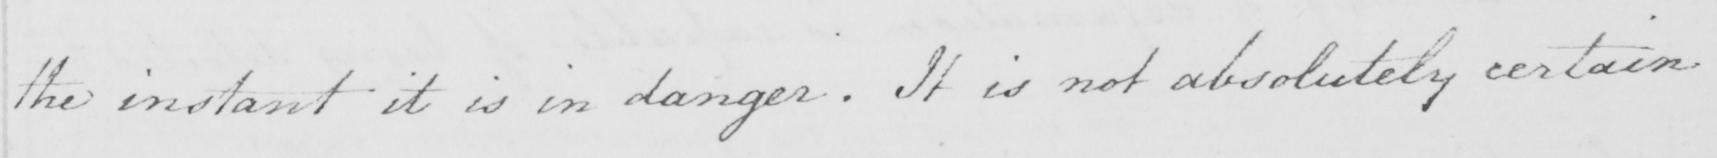What text is written in this handwritten line? the instant it is in danger . It is not absolutely certain 